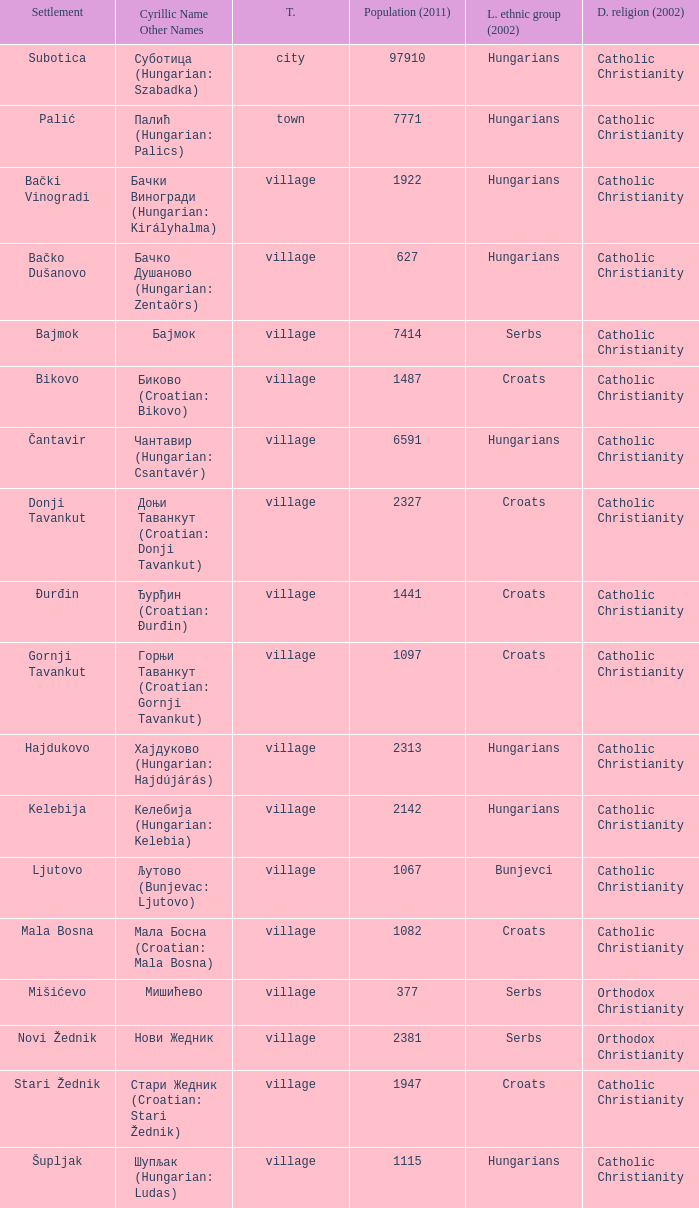What are the cyrillic and other names of the settlement whose population is 6591? Чантавир (Hungarian: Csantavér). 